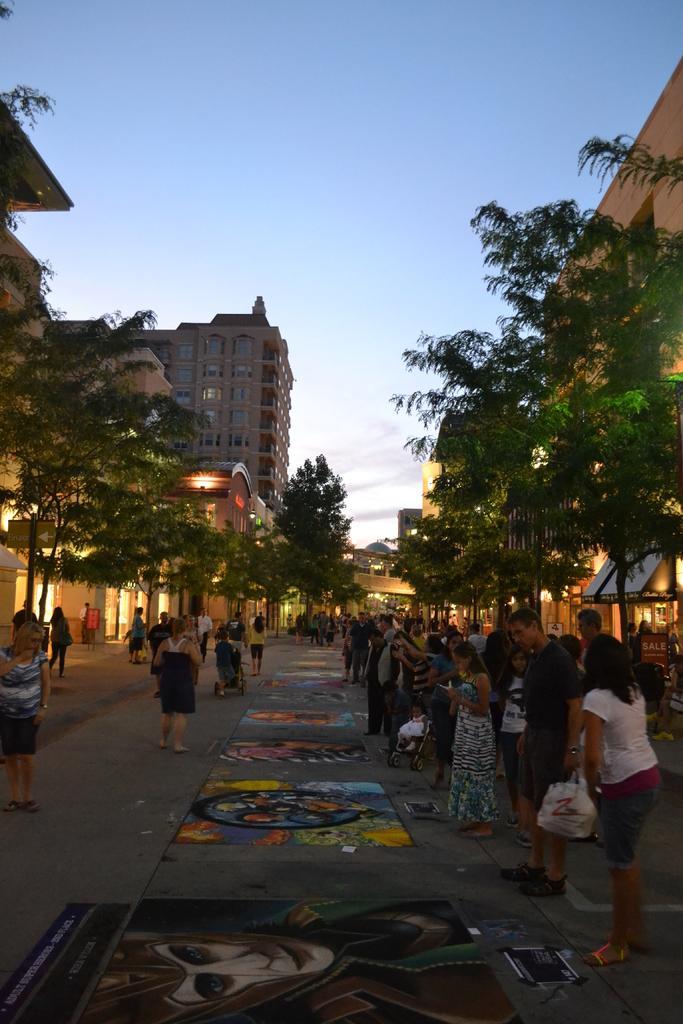In one or two sentences, can you explain what this image depicts? In this image, I can see groups of people standing and few people walking. These are the paintings on the road. I can see the trees. These are the buildings with the windows and lights. 